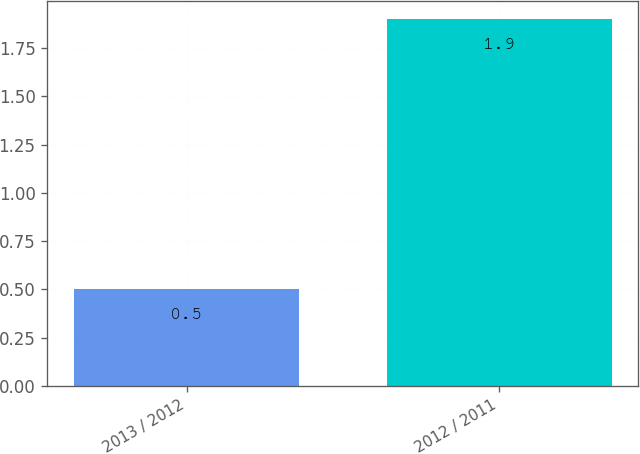Convert chart to OTSL. <chart><loc_0><loc_0><loc_500><loc_500><bar_chart><fcel>2013 / 2012<fcel>2012 / 2011<nl><fcel>0.5<fcel>1.9<nl></chart> 